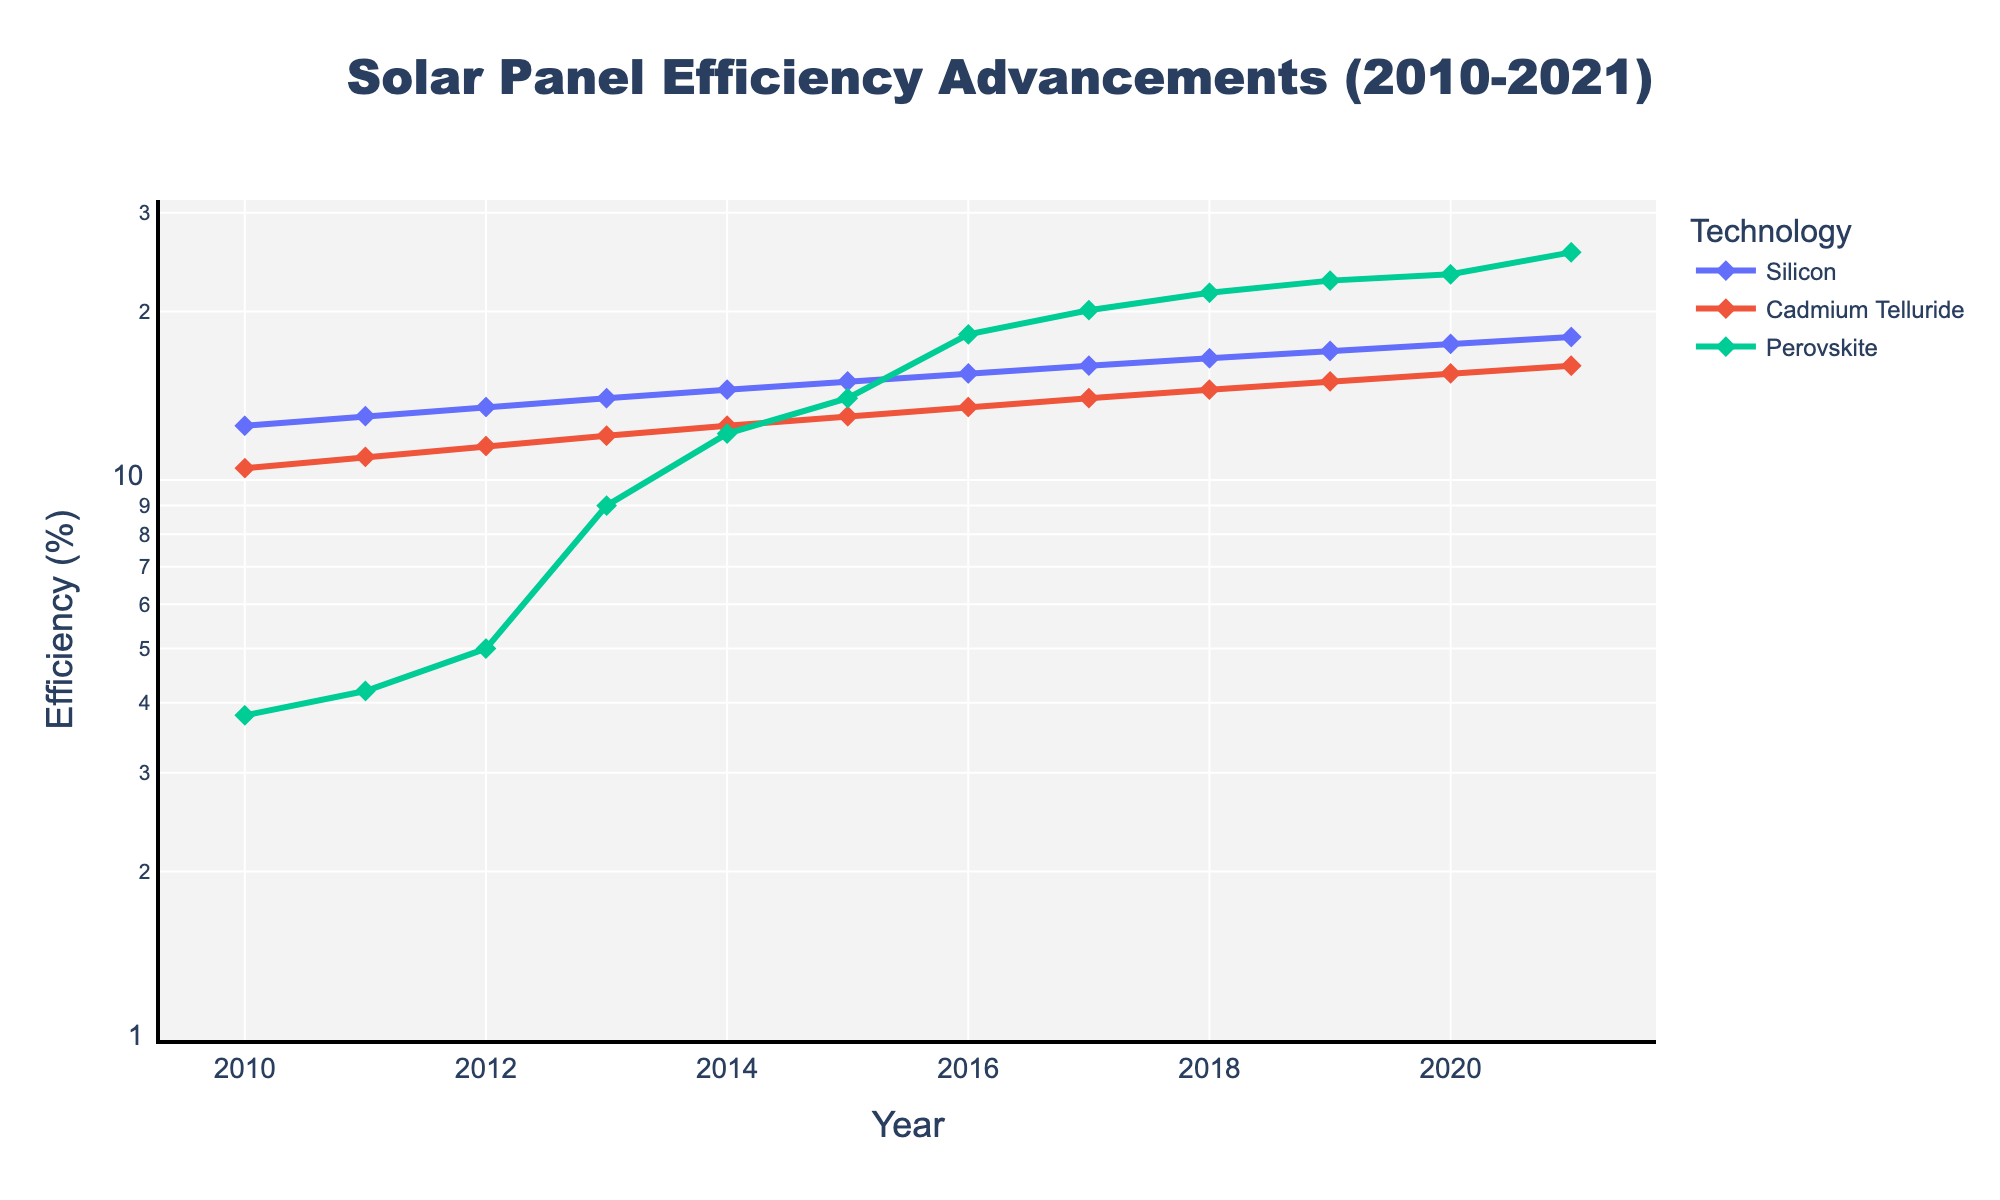What is the title of the figure? The title of the figure is located at the top center and is written in bold, large font.
Answer: Solar Panel Efficiency Advancements (2010-2021) What is the y-axis labeled as? The y-axis title is placed vertically along the y-axis and is labeled to indicate what the axis represents.
Answer: Efficiency (%) What trend can be observed in the efficiency of Perovskite solar panels from 2010 to 2021? By following the Perovskite line, we can observe a significant upward trend in efficiency from 3.8% in 2010 to 25.5% in 2021.
Answer: Increasing trend By how many percentage points did Silicon solar panel efficiency increase from 2010 to 2021? We subtract the efficiency value of Silicon panels in 2010 from the efficiency value in 2021 (18.0 - 12.5).
Answer: 5.5 percentage points Which technology shows the greatest efficiency by 2021? By identifying the highest y-value in 2021 for the different technology lines, we find that Perovskite reaches the highest efficiency.
Answer: Perovskite Compare the efficiency of Cadmium Telluride and Silicon solar panels in 2015. Which one is more efficient and by how much? In 2015, Cadmium Telluride has an efficiency of 13.0%, while Silicon has 15.0%. The difference is 15.0% - 13.0%.
Answer: Silicon by 2 percentage points What is the percentage increase in efficiency of Cadmium Telluride solar panels from 2010 to 2021? The percentage increase is calculated as ((16.0 - 10.5) / 10.5) * 100%.
Answer: 52.38% At what year did Perovskite solar panels exceed the efficiency achieved by Silicon in 2015? Perovskite achieves 15.0% efficiency in the year 2015. By checking the data, we find that this is reached during the same year, 2015.
Answer: 2015 On the log scale y-axis, what is the lowest efficiency value recorded in 2010? The lowest efficiency value in 2010 is observed by locating the lowest point on the y-axis (log scale) for that year, which is for Perovskite panels.
Answer: 3.8% Which technology shows the most rapid advancement in efficiency over the given time period? By comparing the slopes of the lines representing each technology, Perovskite exhibits the steepest slope and biggest efficiency enhancement from 3.8% to 25.5%.
Answer: Perovskite 